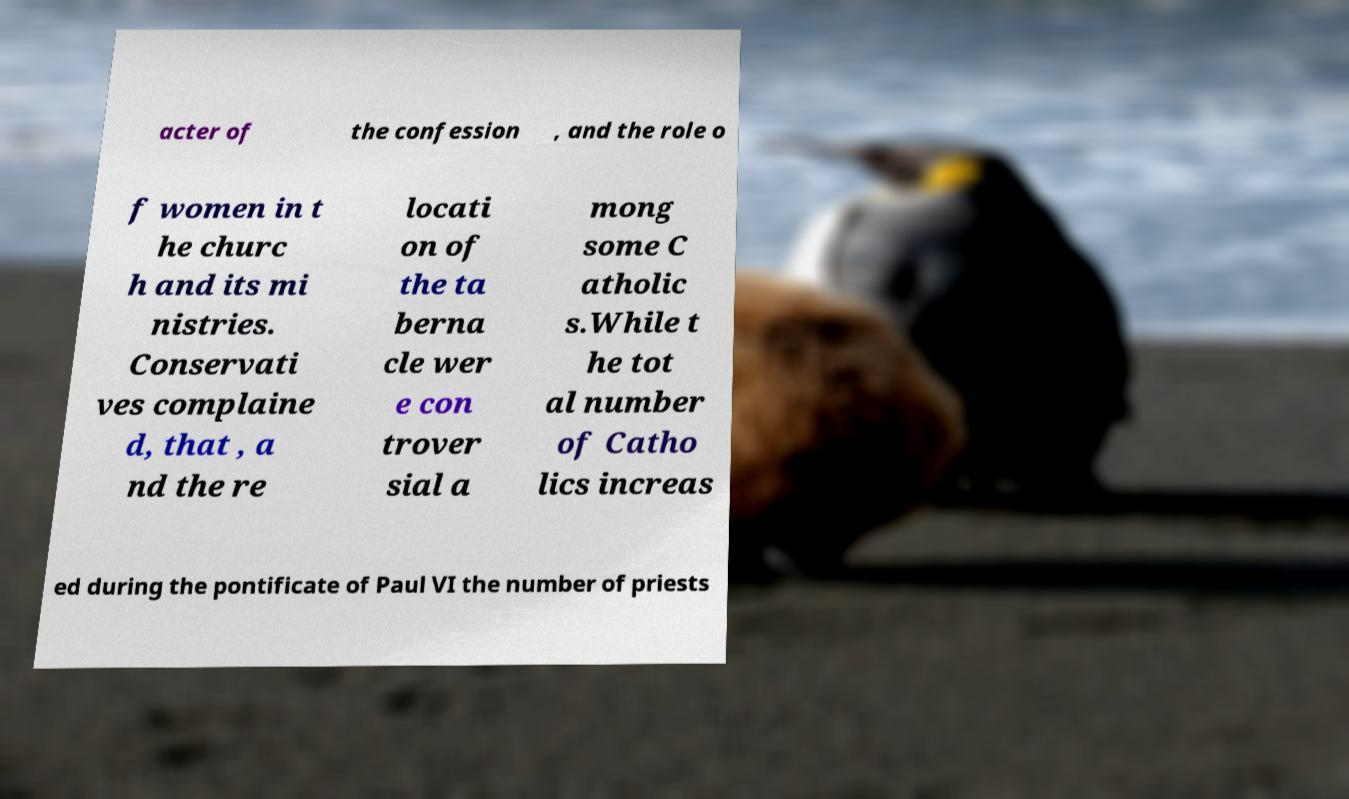For documentation purposes, I need the text within this image transcribed. Could you provide that? acter of the confession , and the role o f women in t he churc h and its mi nistries. Conservati ves complaine d, that , a nd the re locati on of the ta berna cle wer e con trover sial a mong some C atholic s.While t he tot al number of Catho lics increas ed during the pontificate of Paul VI the number of priests 